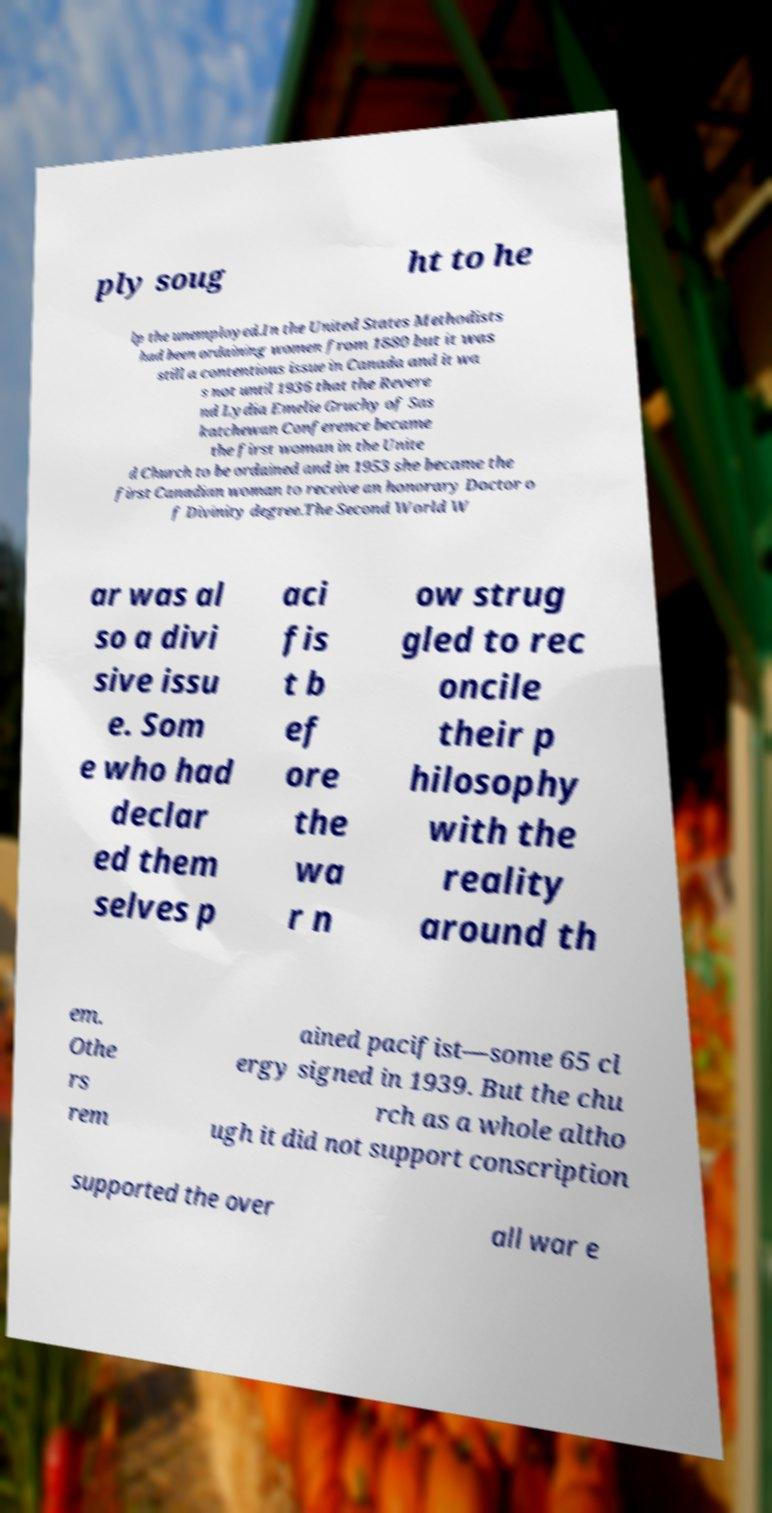Can you read and provide the text displayed in the image?This photo seems to have some interesting text. Can you extract and type it out for me? ply soug ht to he lp the unemployed.In the United States Methodists had been ordaining women from 1880 but it was still a contentious issue in Canada and it wa s not until 1936 that the Revere nd Lydia Emelie Gruchy of Sas katchewan Conference became the first woman in the Unite d Church to be ordained and in 1953 she became the first Canadian woman to receive an honorary Doctor o f Divinity degree.The Second World W ar was al so a divi sive issu e. Som e who had declar ed them selves p aci fis t b ef ore the wa r n ow strug gled to rec oncile their p hilosophy with the reality around th em. Othe rs rem ained pacifist—some 65 cl ergy signed in 1939. But the chu rch as a whole altho ugh it did not support conscription supported the over all war e 